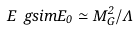<formula> <loc_0><loc_0><loc_500><loc_500>E \ g s i m E _ { 0 } \simeq M _ { G } ^ { 2 } / \Lambda</formula> 